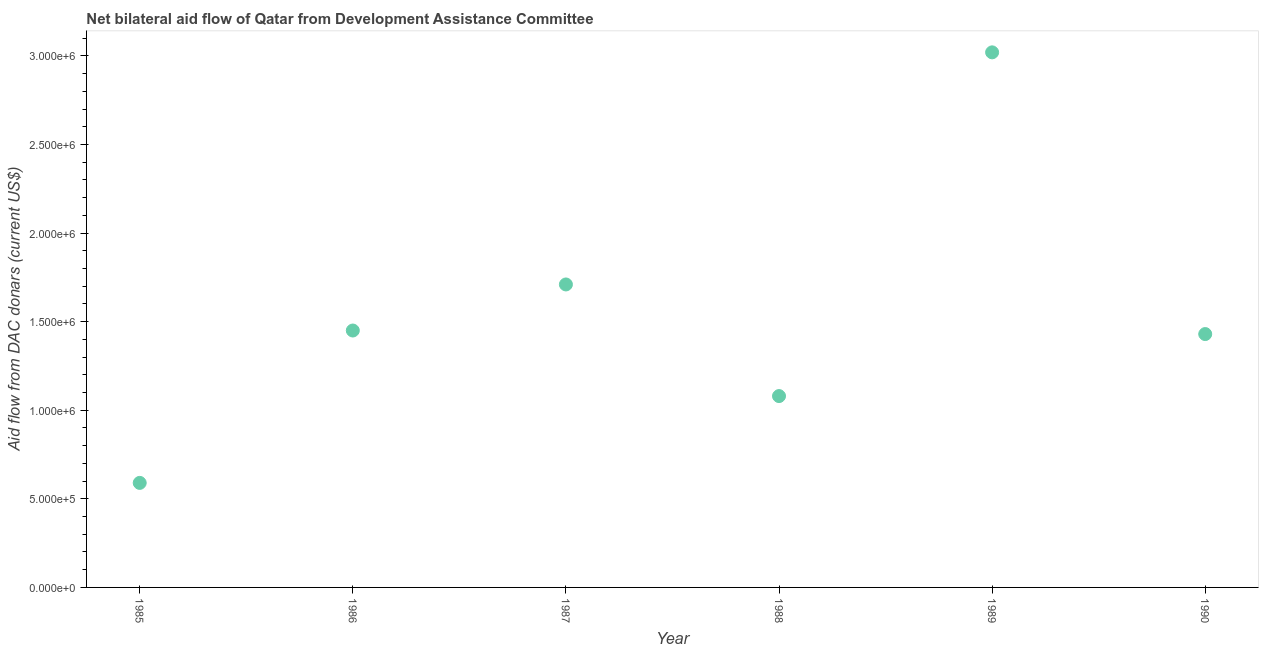What is the net bilateral aid flows from dac donors in 1985?
Offer a very short reply. 5.90e+05. Across all years, what is the maximum net bilateral aid flows from dac donors?
Your answer should be compact. 3.02e+06. Across all years, what is the minimum net bilateral aid flows from dac donors?
Offer a terse response. 5.90e+05. In which year was the net bilateral aid flows from dac donors maximum?
Keep it short and to the point. 1989. In which year was the net bilateral aid flows from dac donors minimum?
Keep it short and to the point. 1985. What is the sum of the net bilateral aid flows from dac donors?
Ensure brevity in your answer.  9.28e+06. What is the difference between the net bilateral aid flows from dac donors in 1986 and 1990?
Ensure brevity in your answer.  2.00e+04. What is the average net bilateral aid flows from dac donors per year?
Your response must be concise. 1.55e+06. What is the median net bilateral aid flows from dac donors?
Make the answer very short. 1.44e+06. In how many years, is the net bilateral aid flows from dac donors greater than 3000000 US$?
Make the answer very short. 1. Do a majority of the years between 1988 and 1989 (inclusive) have net bilateral aid flows from dac donors greater than 800000 US$?
Keep it short and to the point. Yes. What is the ratio of the net bilateral aid flows from dac donors in 1987 to that in 1990?
Your response must be concise. 1.2. Is the net bilateral aid flows from dac donors in 1987 less than that in 1990?
Keep it short and to the point. No. What is the difference between the highest and the second highest net bilateral aid flows from dac donors?
Offer a terse response. 1.31e+06. What is the difference between the highest and the lowest net bilateral aid flows from dac donors?
Provide a short and direct response. 2.43e+06. Are the values on the major ticks of Y-axis written in scientific E-notation?
Make the answer very short. Yes. Does the graph contain grids?
Your answer should be very brief. No. What is the title of the graph?
Offer a very short reply. Net bilateral aid flow of Qatar from Development Assistance Committee. What is the label or title of the Y-axis?
Provide a short and direct response. Aid flow from DAC donars (current US$). What is the Aid flow from DAC donars (current US$) in 1985?
Provide a short and direct response. 5.90e+05. What is the Aid flow from DAC donars (current US$) in 1986?
Your response must be concise. 1.45e+06. What is the Aid flow from DAC donars (current US$) in 1987?
Your answer should be very brief. 1.71e+06. What is the Aid flow from DAC donars (current US$) in 1988?
Make the answer very short. 1.08e+06. What is the Aid flow from DAC donars (current US$) in 1989?
Make the answer very short. 3.02e+06. What is the Aid flow from DAC donars (current US$) in 1990?
Keep it short and to the point. 1.43e+06. What is the difference between the Aid flow from DAC donars (current US$) in 1985 and 1986?
Offer a terse response. -8.60e+05. What is the difference between the Aid flow from DAC donars (current US$) in 1985 and 1987?
Your response must be concise. -1.12e+06. What is the difference between the Aid flow from DAC donars (current US$) in 1985 and 1988?
Provide a short and direct response. -4.90e+05. What is the difference between the Aid flow from DAC donars (current US$) in 1985 and 1989?
Your answer should be very brief. -2.43e+06. What is the difference between the Aid flow from DAC donars (current US$) in 1985 and 1990?
Make the answer very short. -8.40e+05. What is the difference between the Aid flow from DAC donars (current US$) in 1986 and 1988?
Keep it short and to the point. 3.70e+05. What is the difference between the Aid flow from DAC donars (current US$) in 1986 and 1989?
Give a very brief answer. -1.57e+06. What is the difference between the Aid flow from DAC donars (current US$) in 1987 and 1988?
Your answer should be compact. 6.30e+05. What is the difference between the Aid flow from DAC donars (current US$) in 1987 and 1989?
Your answer should be compact. -1.31e+06. What is the difference between the Aid flow from DAC donars (current US$) in 1987 and 1990?
Offer a very short reply. 2.80e+05. What is the difference between the Aid flow from DAC donars (current US$) in 1988 and 1989?
Your answer should be very brief. -1.94e+06. What is the difference between the Aid flow from DAC donars (current US$) in 1988 and 1990?
Ensure brevity in your answer.  -3.50e+05. What is the difference between the Aid flow from DAC donars (current US$) in 1989 and 1990?
Give a very brief answer. 1.59e+06. What is the ratio of the Aid flow from DAC donars (current US$) in 1985 to that in 1986?
Ensure brevity in your answer.  0.41. What is the ratio of the Aid flow from DAC donars (current US$) in 1985 to that in 1987?
Your response must be concise. 0.34. What is the ratio of the Aid flow from DAC donars (current US$) in 1985 to that in 1988?
Keep it short and to the point. 0.55. What is the ratio of the Aid flow from DAC donars (current US$) in 1985 to that in 1989?
Offer a very short reply. 0.2. What is the ratio of the Aid flow from DAC donars (current US$) in 1985 to that in 1990?
Keep it short and to the point. 0.41. What is the ratio of the Aid flow from DAC donars (current US$) in 1986 to that in 1987?
Your answer should be compact. 0.85. What is the ratio of the Aid flow from DAC donars (current US$) in 1986 to that in 1988?
Make the answer very short. 1.34. What is the ratio of the Aid flow from DAC donars (current US$) in 1986 to that in 1989?
Provide a short and direct response. 0.48. What is the ratio of the Aid flow from DAC donars (current US$) in 1986 to that in 1990?
Provide a succinct answer. 1.01. What is the ratio of the Aid flow from DAC donars (current US$) in 1987 to that in 1988?
Your response must be concise. 1.58. What is the ratio of the Aid flow from DAC donars (current US$) in 1987 to that in 1989?
Provide a succinct answer. 0.57. What is the ratio of the Aid flow from DAC donars (current US$) in 1987 to that in 1990?
Ensure brevity in your answer.  1.2. What is the ratio of the Aid flow from DAC donars (current US$) in 1988 to that in 1989?
Provide a short and direct response. 0.36. What is the ratio of the Aid flow from DAC donars (current US$) in 1988 to that in 1990?
Provide a succinct answer. 0.76. What is the ratio of the Aid flow from DAC donars (current US$) in 1989 to that in 1990?
Provide a succinct answer. 2.11. 